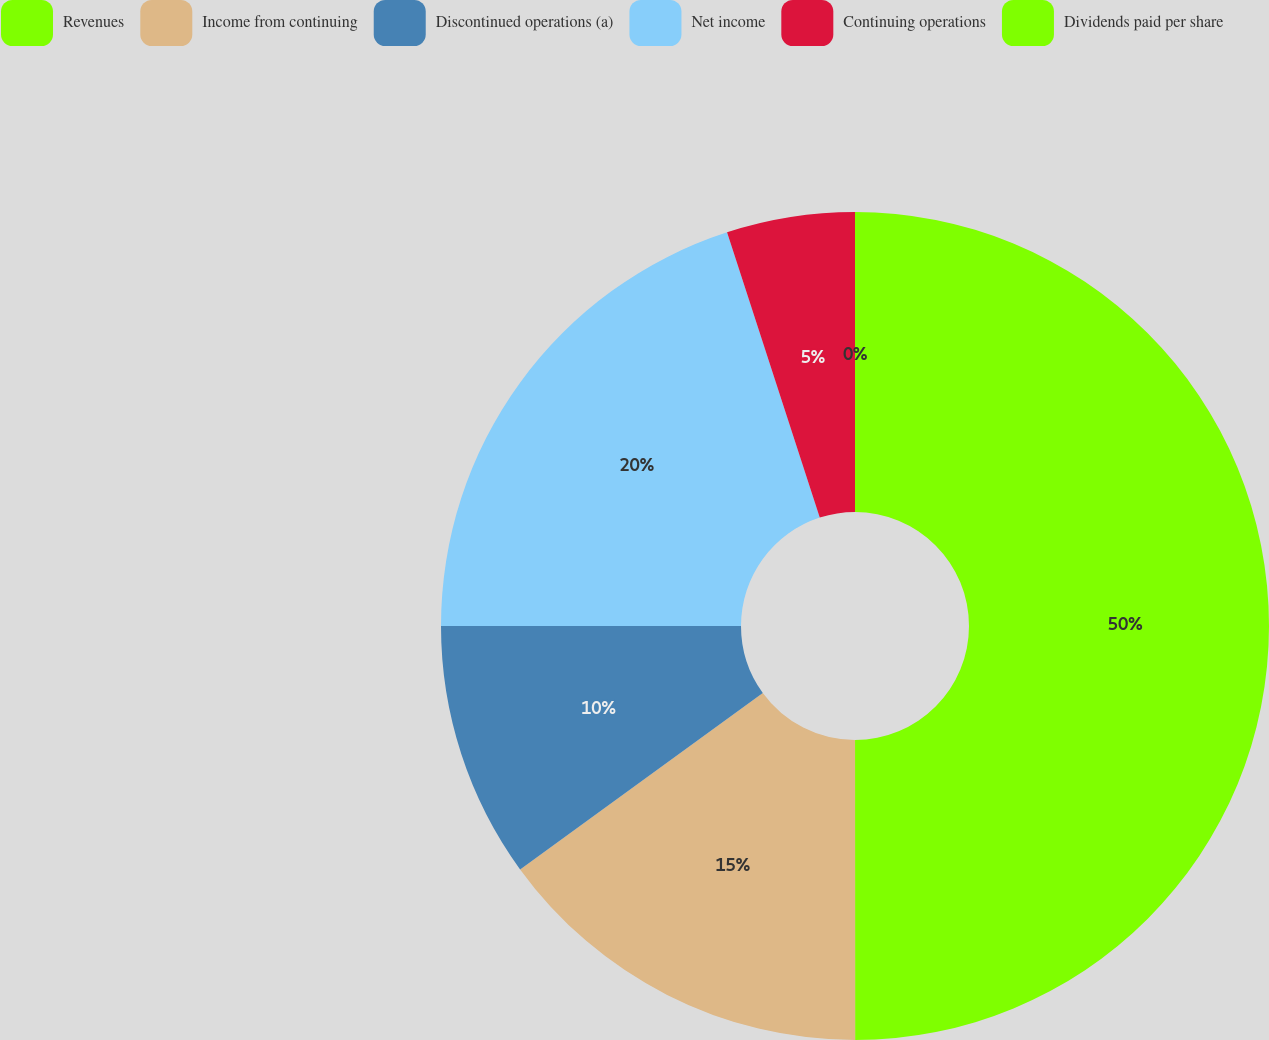Convert chart to OTSL. <chart><loc_0><loc_0><loc_500><loc_500><pie_chart><fcel>Revenues<fcel>Income from continuing<fcel>Discontinued operations (a)<fcel>Net income<fcel>Continuing operations<fcel>Dividends paid per share<nl><fcel>49.99%<fcel>15.0%<fcel>10.0%<fcel>20.0%<fcel>5.0%<fcel>0.0%<nl></chart> 